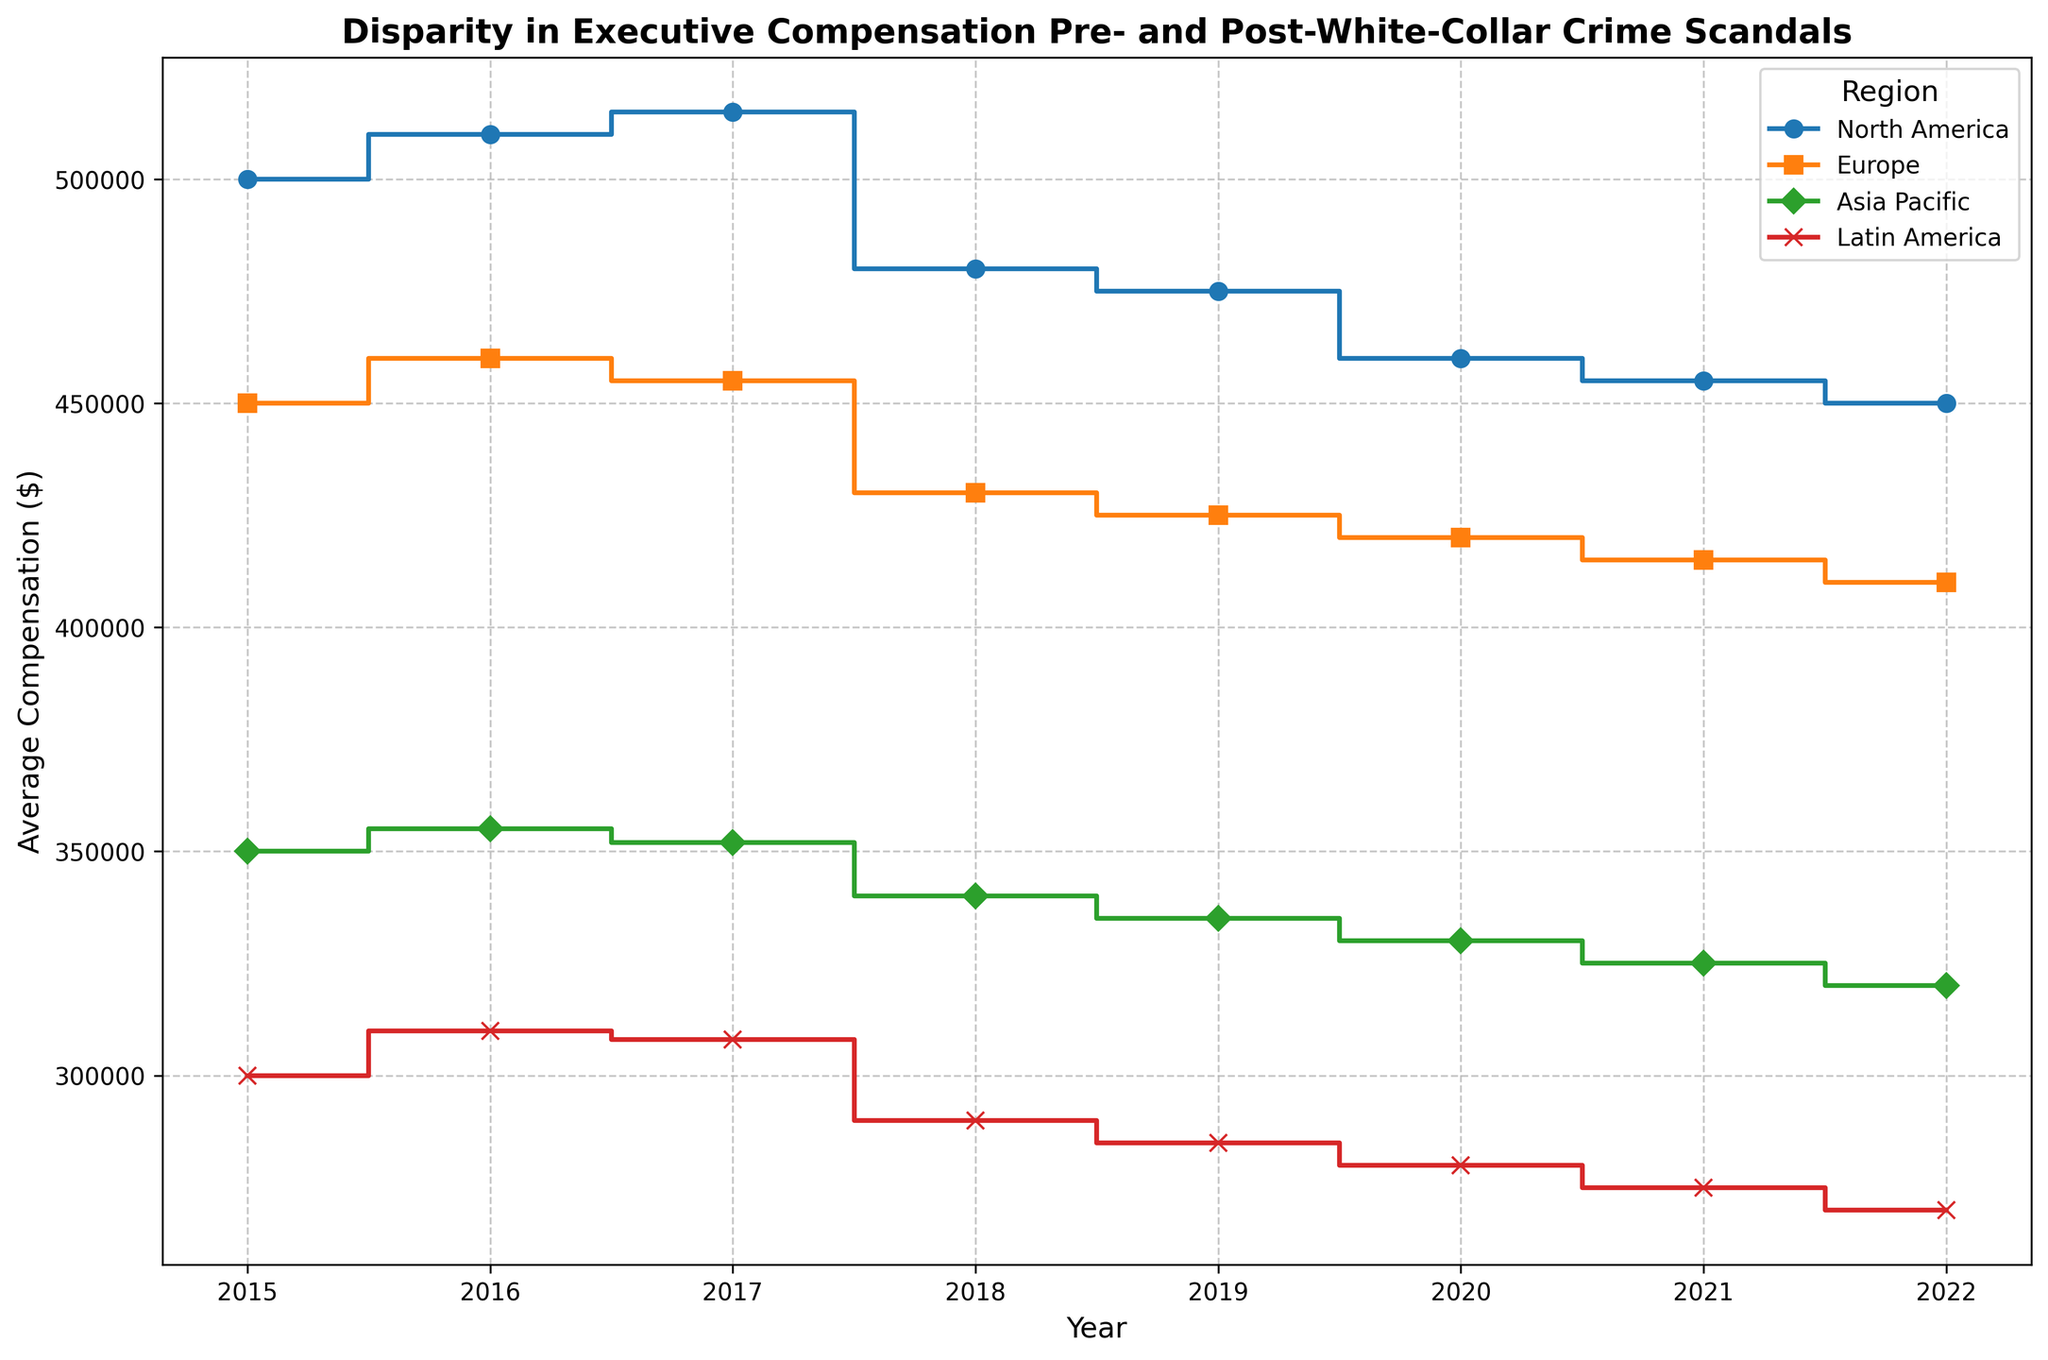What was the average compensation in North America in 2019? Look at the step height for North America in 2019, which is around $475,000.
Answer: $475,000 Which region showed the largest absolute drop in compensation from 2017 to 2022? Calculate the difference in compensation from 2017 to 2022 for each region: North America (515,000 - 450,000 = 65,000), Europe (455,000 - 410,000 = 45,000), Asia Pacific (352,000 - 320,000 = 32,000), Latin America (308,000 - 270,000 = 38,000). The largest drop is in North America.
Answer: North America Is there a region where the average compensation never decreased from 2015 to 2022? Check each region's plot between each year; the compensation decreases for all regions at various points. No region avoids a decrease.
Answer: No Which region had the highest average compensation in 2020? Compare the heights of the steps for each region in 2020. North America has the highest at $460,000.
Answer: North America What is the visual pattern seen for the trend of compensations in Latin America post-2017? Notice the consistent downward step pattern in Latin America's plot from 2017 to 2022.
Answer: Consistent decrease By how much did the average compensation in Europe decrease from 2017 to 2018, and how does this compare to the decrease in the same period for North America? Calculate the difference for each region from 2017 to 2018: Europe (455,000 - 430,000 = 25,000), North America (515,000 - 480,000 = 35,000). Compare the values.
Answer: Europe's decrease: $25,000, North America's decrease: $35,000 Which region had the smallest average compensation in 2015, and what was it? Look at the starting step heights in 2015 for each region; Latin America's is the lowest at $300,000.
Answer: Latin America, $300,000 In which year did Asia Pacific see a peak in average compensation, and what was the value? Identify the highest step in the Asia Pacific plot which is in 2016, with $355,000.
Answer: 2016, $355,000 Did any region experience periods of consistent or steady compensation values, and in which years? Check for flat steps in any region's plot. North America shows steady compensation in the years 2021 and 2022 ($455,000).
Answer: North America, 2021-2022 